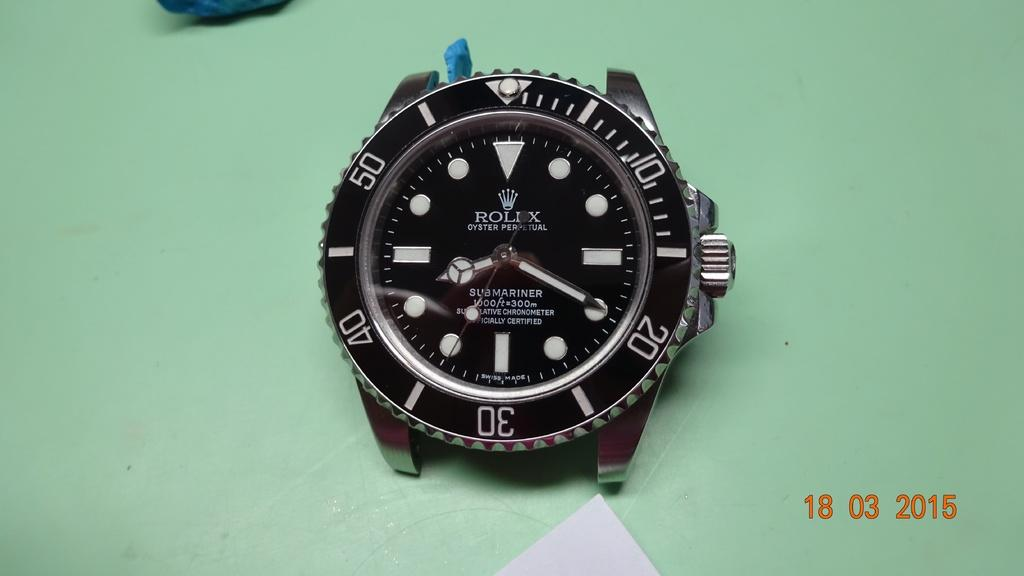<image>
Share a concise interpretation of the image provided. Face of a watch which says the word ROLEX on it. 